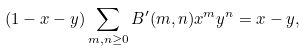<formula> <loc_0><loc_0><loc_500><loc_500>( 1 - x - y ) \sum _ { m , n \geq 0 } B ^ { \prime } ( m , n ) x ^ { m } y ^ { n } = x - y ,</formula> 